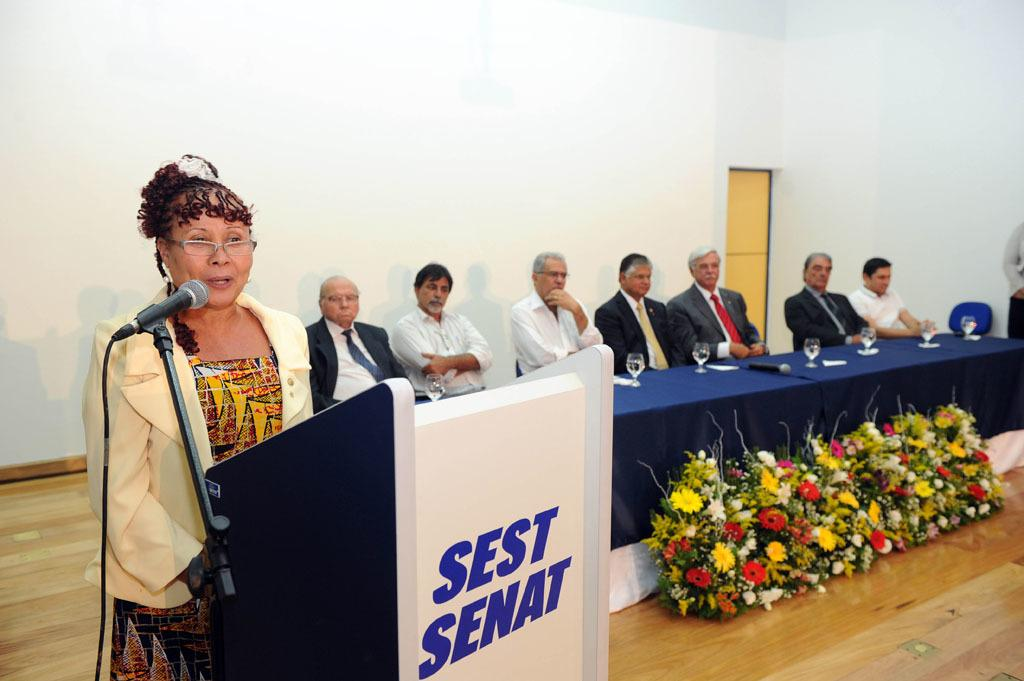<image>
Render a clear and concise summary of the photo. A woman is speaking from a podium that says "Sest Senat" on it. 